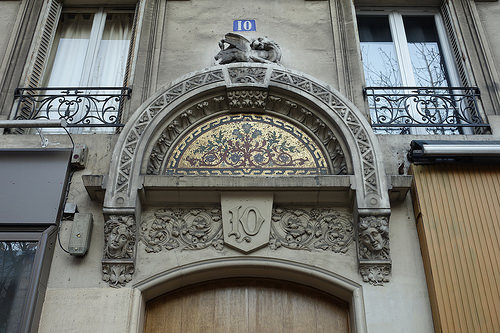<image>
Can you confirm if the house number is above the statue? Yes. The house number is positioned above the statue in the vertical space, higher up in the scene. 